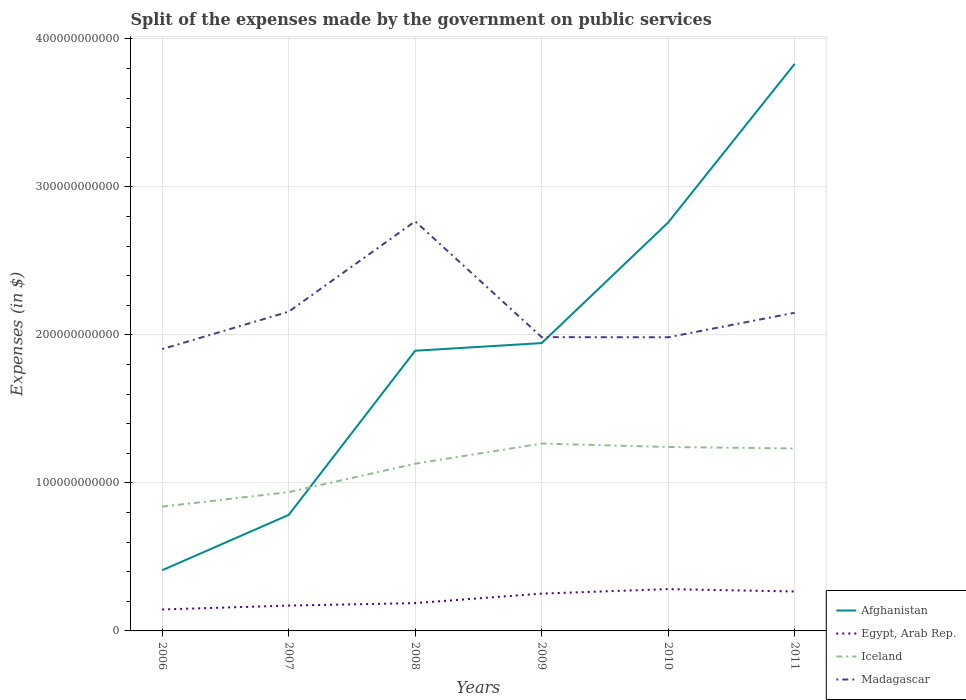How many different coloured lines are there?
Provide a succinct answer. 4. Is the number of lines equal to the number of legend labels?
Make the answer very short. Yes. Across all years, what is the maximum expenses made by the government on public services in Afghanistan?
Offer a very short reply. 4.10e+1. In which year was the expenses made by the government on public services in Egypt, Arab Rep. maximum?
Offer a very short reply. 2006. What is the total expenses made by the government on public services in Iceland in the graph?
Your response must be concise. -4.26e+1. What is the difference between the highest and the second highest expenses made by the government on public services in Madagascar?
Provide a succinct answer. 8.63e+1. How many lines are there?
Your answer should be compact. 4. What is the difference between two consecutive major ticks on the Y-axis?
Your answer should be very brief. 1.00e+11. Does the graph contain any zero values?
Ensure brevity in your answer.  No. Where does the legend appear in the graph?
Offer a terse response. Bottom right. How many legend labels are there?
Make the answer very short. 4. What is the title of the graph?
Make the answer very short. Split of the expenses made by the government on public services. Does "Burkina Faso" appear as one of the legend labels in the graph?
Ensure brevity in your answer.  No. What is the label or title of the Y-axis?
Keep it short and to the point. Expenses (in $). What is the Expenses (in $) in Afghanistan in 2006?
Your response must be concise. 4.10e+1. What is the Expenses (in $) in Egypt, Arab Rep. in 2006?
Ensure brevity in your answer.  1.45e+1. What is the Expenses (in $) in Iceland in 2006?
Ensure brevity in your answer.  8.39e+1. What is the Expenses (in $) of Madagascar in 2006?
Your answer should be very brief. 1.90e+11. What is the Expenses (in $) in Afghanistan in 2007?
Your answer should be very brief. 7.84e+1. What is the Expenses (in $) of Egypt, Arab Rep. in 2007?
Ensure brevity in your answer.  1.71e+1. What is the Expenses (in $) of Iceland in 2007?
Offer a terse response. 9.38e+1. What is the Expenses (in $) of Madagascar in 2007?
Make the answer very short. 2.16e+11. What is the Expenses (in $) in Afghanistan in 2008?
Provide a succinct answer. 1.89e+11. What is the Expenses (in $) in Egypt, Arab Rep. in 2008?
Give a very brief answer. 1.88e+1. What is the Expenses (in $) of Iceland in 2008?
Make the answer very short. 1.13e+11. What is the Expenses (in $) in Madagascar in 2008?
Your answer should be very brief. 2.77e+11. What is the Expenses (in $) of Afghanistan in 2009?
Make the answer very short. 1.94e+11. What is the Expenses (in $) in Egypt, Arab Rep. in 2009?
Make the answer very short. 2.52e+1. What is the Expenses (in $) in Iceland in 2009?
Keep it short and to the point. 1.27e+11. What is the Expenses (in $) in Madagascar in 2009?
Give a very brief answer. 1.98e+11. What is the Expenses (in $) in Afghanistan in 2010?
Ensure brevity in your answer.  2.76e+11. What is the Expenses (in $) in Egypt, Arab Rep. in 2010?
Make the answer very short. 2.82e+1. What is the Expenses (in $) in Iceland in 2010?
Make the answer very short. 1.24e+11. What is the Expenses (in $) in Madagascar in 2010?
Provide a succinct answer. 1.98e+11. What is the Expenses (in $) in Afghanistan in 2011?
Offer a terse response. 3.83e+11. What is the Expenses (in $) of Egypt, Arab Rep. in 2011?
Keep it short and to the point. 2.66e+1. What is the Expenses (in $) in Iceland in 2011?
Give a very brief answer. 1.23e+11. What is the Expenses (in $) of Madagascar in 2011?
Offer a terse response. 2.15e+11. Across all years, what is the maximum Expenses (in $) in Afghanistan?
Provide a short and direct response. 3.83e+11. Across all years, what is the maximum Expenses (in $) in Egypt, Arab Rep.?
Make the answer very short. 2.82e+1. Across all years, what is the maximum Expenses (in $) in Iceland?
Provide a succinct answer. 1.27e+11. Across all years, what is the maximum Expenses (in $) in Madagascar?
Your answer should be compact. 2.77e+11. Across all years, what is the minimum Expenses (in $) of Afghanistan?
Give a very brief answer. 4.10e+1. Across all years, what is the minimum Expenses (in $) of Egypt, Arab Rep.?
Provide a succinct answer. 1.45e+1. Across all years, what is the minimum Expenses (in $) of Iceland?
Ensure brevity in your answer.  8.39e+1. Across all years, what is the minimum Expenses (in $) of Madagascar?
Offer a terse response. 1.90e+11. What is the total Expenses (in $) in Afghanistan in the graph?
Offer a very short reply. 1.16e+12. What is the total Expenses (in $) in Egypt, Arab Rep. in the graph?
Make the answer very short. 1.30e+11. What is the total Expenses (in $) of Iceland in the graph?
Provide a succinct answer. 6.65e+11. What is the total Expenses (in $) in Madagascar in the graph?
Your response must be concise. 1.29e+12. What is the difference between the Expenses (in $) of Afghanistan in 2006 and that in 2007?
Your answer should be compact. -3.74e+1. What is the difference between the Expenses (in $) of Egypt, Arab Rep. in 2006 and that in 2007?
Give a very brief answer. -2.63e+09. What is the difference between the Expenses (in $) of Iceland in 2006 and that in 2007?
Provide a succinct answer. -9.81e+09. What is the difference between the Expenses (in $) of Madagascar in 2006 and that in 2007?
Give a very brief answer. -2.52e+1. What is the difference between the Expenses (in $) of Afghanistan in 2006 and that in 2008?
Keep it short and to the point. -1.48e+11. What is the difference between the Expenses (in $) in Egypt, Arab Rep. in 2006 and that in 2008?
Keep it short and to the point. -4.30e+09. What is the difference between the Expenses (in $) of Iceland in 2006 and that in 2008?
Ensure brevity in your answer.  -2.90e+1. What is the difference between the Expenses (in $) of Madagascar in 2006 and that in 2008?
Make the answer very short. -8.63e+1. What is the difference between the Expenses (in $) of Afghanistan in 2006 and that in 2009?
Make the answer very short. -1.53e+11. What is the difference between the Expenses (in $) of Egypt, Arab Rep. in 2006 and that in 2009?
Give a very brief answer. -1.07e+1. What is the difference between the Expenses (in $) of Iceland in 2006 and that in 2009?
Your response must be concise. -4.26e+1. What is the difference between the Expenses (in $) of Madagascar in 2006 and that in 2009?
Your answer should be very brief. -8.07e+09. What is the difference between the Expenses (in $) of Afghanistan in 2006 and that in 2010?
Your response must be concise. -2.35e+11. What is the difference between the Expenses (in $) of Egypt, Arab Rep. in 2006 and that in 2010?
Ensure brevity in your answer.  -1.38e+1. What is the difference between the Expenses (in $) of Iceland in 2006 and that in 2010?
Offer a terse response. -4.03e+1. What is the difference between the Expenses (in $) of Madagascar in 2006 and that in 2010?
Offer a very short reply. -7.98e+09. What is the difference between the Expenses (in $) in Afghanistan in 2006 and that in 2011?
Your answer should be very brief. -3.42e+11. What is the difference between the Expenses (in $) in Egypt, Arab Rep. in 2006 and that in 2011?
Provide a short and direct response. -1.22e+1. What is the difference between the Expenses (in $) of Iceland in 2006 and that in 2011?
Offer a terse response. -3.93e+1. What is the difference between the Expenses (in $) in Madagascar in 2006 and that in 2011?
Give a very brief answer. -2.45e+1. What is the difference between the Expenses (in $) of Afghanistan in 2007 and that in 2008?
Provide a short and direct response. -1.11e+11. What is the difference between the Expenses (in $) of Egypt, Arab Rep. in 2007 and that in 2008?
Ensure brevity in your answer.  -1.67e+09. What is the difference between the Expenses (in $) of Iceland in 2007 and that in 2008?
Your response must be concise. -1.92e+1. What is the difference between the Expenses (in $) in Madagascar in 2007 and that in 2008?
Offer a very short reply. -6.11e+1. What is the difference between the Expenses (in $) in Afghanistan in 2007 and that in 2009?
Provide a succinct answer. -1.16e+11. What is the difference between the Expenses (in $) of Egypt, Arab Rep. in 2007 and that in 2009?
Your answer should be very brief. -8.08e+09. What is the difference between the Expenses (in $) in Iceland in 2007 and that in 2009?
Make the answer very short. -3.28e+1. What is the difference between the Expenses (in $) in Madagascar in 2007 and that in 2009?
Ensure brevity in your answer.  1.72e+1. What is the difference between the Expenses (in $) in Afghanistan in 2007 and that in 2010?
Provide a short and direct response. -1.98e+11. What is the difference between the Expenses (in $) in Egypt, Arab Rep. in 2007 and that in 2010?
Your answer should be compact. -1.11e+1. What is the difference between the Expenses (in $) of Iceland in 2007 and that in 2010?
Provide a succinct answer. -3.05e+1. What is the difference between the Expenses (in $) in Madagascar in 2007 and that in 2010?
Ensure brevity in your answer.  1.73e+1. What is the difference between the Expenses (in $) of Afghanistan in 2007 and that in 2011?
Give a very brief answer. -3.05e+11. What is the difference between the Expenses (in $) of Egypt, Arab Rep. in 2007 and that in 2011?
Make the answer very short. -9.52e+09. What is the difference between the Expenses (in $) of Iceland in 2007 and that in 2011?
Provide a short and direct response. -2.95e+1. What is the difference between the Expenses (in $) of Madagascar in 2007 and that in 2011?
Your response must be concise. 7.27e+08. What is the difference between the Expenses (in $) in Afghanistan in 2008 and that in 2009?
Make the answer very short. -5.15e+09. What is the difference between the Expenses (in $) of Egypt, Arab Rep. in 2008 and that in 2009?
Give a very brief answer. -6.41e+09. What is the difference between the Expenses (in $) in Iceland in 2008 and that in 2009?
Ensure brevity in your answer.  -1.36e+1. What is the difference between the Expenses (in $) in Madagascar in 2008 and that in 2009?
Your response must be concise. 7.82e+1. What is the difference between the Expenses (in $) in Afghanistan in 2008 and that in 2010?
Provide a succinct answer. -8.66e+1. What is the difference between the Expenses (in $) in Egypt, Arab Rep. in 2008 and that in 2010?
Your response must be concise. -9.46e+09. What is the difference between the Expenses (in $) in Iceland in 2008 and that in 2010?
Ensure brevity in your answer.  -1.13e+1. What is the difference between the Expenses (in $) of Madagascar in 2008 and that in 2010?
Offer a terse response. 7.83e+1. What is the difference between the Expenses (in $) in Afghanistan in 2008 and that in 2011?
Provide a succinct answer. -1.94e+11. What is the difference between the Expenses (in $) in Egypt, Arab Rep. in 2008 and that in 2011?
Keep it short and to the point. -7.86e+09. What is the difference between the Expenses (in $) of Iceland in 2008 and that in 2011?
Provide a succinct answer. -1.03e+1. What is the difference between the Expenses (in $) in Madagascar in 2008 and that in 2011?
Give a very brief answer. 6.18e+1. What is the difference between the Expenses (in $) of Afghanistan in 2009 and that in 2010?
Provide a succinct answer. -8.15e+1. What is the difference between the Expenses (in $) in Egypt, Arab Rep. in 2009 and that in 2010?
Provide a short and direct response. -3.04e+09. What is the difference between the Expenses (in $) in Iceland in 2009 and that in 2010?
Your response must be concise. 2.31e+09. What is the difference between the Expenses (in $) of Madagascar in 2009 and that in 2010?
Provide a succinct answer. 9.30e+07. What is the difference between the Expenses (in $) of Afghanistan in 2009 and that in 2011?
Offer a terse response. -1.89e+11. What is the difference between the Expenses (in $) of Egypt, Arab Rep. in 2009 and that in 2011?
Keep it short and to the point. -1.44e+09. What is the difference between the Expenses (in $) of Iceland in 2009 and that in 2011?
Your answer should be very brief. 3.32e+09. What is the difference between the Expenses (in $) of Madagascar in 2009 and that in 2011?
Give a very brief answer. -1.65e+1. What is the difference between the Expenses (in $) of Afghanistan in 2010 and that in 2011?
Ensure brevity in your answer.  -1.07e+11. What is the difference between the Expenses (in $) in Egypt, Arab Rep. in 2010 and that in 2011?
Your answer should be very brief. 1.60e+09. What is the difference between the Expenses (in $) in Iceland in 2010 and that in 2011?
Your answer should be very brief. 1.01e+09. What is the difference between the Expenses (in $) of Madagascar in 2010 and that in 2011?
Your answer should be very brief. -1.65e+1. What is the difference between the Expenses (in $) in Afghanistan in 2006 and the Expenses (in $) in Egypt, Arab Rep. in 2007?
Your answer should be compact. 2.39e+1. What is the difference between the Expenses (in $) in Afghanistan in 2006 and the Expenses (in $) in Iceland in 2007?
Offer a terse response. -5.28e+1. What is the difference between the Expenses (in $) of Afghanistan in 2006 and the Expenses (in $) of Madagascar in 2007?
Your answer should be very brief. -1.75e+11. What is the difference between the Expenses (in $) in Egypt, Arab Rep. in 2006 and the Expenses (in $) in Iceland in 2007?
Your response must be concise. -7.93e+1. What is the difference between the Expenses (in $) of Egypt, Arab Rep. in 2006 and the Expenses (in $) of Madagascar in 2007?
Your answer should be compact. -2.01e+11. What is the difference between the Expenses (in $) of Iceland in 2006 and the Expenses (in $) of Madagascar in 2007?
Your answer should be very brief. -1.32e+11. What is the difference between the Expenses (in $) in Afghanistan in 2006 and the Expenses (in $) in Egypt, Arab Rep. in 2008?
Your answer should be very brief. 2.22e+1. What is the difference between the Expenses (in $) in Afghanistan in 2006 and the Expenses (in $) in Iceland in 2008?
Make the answer very short. -7.20e+1. What is the difference between the Expenses (in $) of Afghanistan in 2006 and the Expenses (in $) of Madagascar in 2008?
Make the answer very short. -2.36e+11. What is the difference between the Expenses (in $) in Egypt, Arab Rep. in 2006 and the Expenses (in $) in Iceland in 2008?
Keep it short and to the point. -9.85e+1. What is the difference between the Expenses (in $) of Egypt, Arab Rep. in 2006 and the Expenses (in $) of Madagascar in 2008?
Offer a very short reply. -2.62e+11. What is the difference between the Expenses (in $) in Iceland in 2006 and the Expenses (in $) in Madagascar in 2008?
Provide a succinct answer. -1.93e+11. What is the difference between the Expenses (in $) of Afghanistan in 2006 and the Expenses (in $) of Egypt, Arab Rep. in 2009?
Provide a succinct answer. 1.58e+1. What is the difference between the Expenses (in $) in Afghanistan in 2006 and the Expenses (in $) in Iceland in 2009?
Your answer should be compact. -8.56e+1. What is the difference between the Expenses (in $) of Afghanistan in 2006 and the Expenses (in $) of Madagascar in 2009?
Your response must be concise. -1.57e+11. What is the difference between the Expenses (in $) in Egypt, Arab Rep. in 2006 and the Expenses (in $) in Iceland in 2009?
Provide a short and direct response. -1.12e+11. What is the difference between the Expenses (in $) of Egypt, Arab Rep. in 2006 and the Expenses (in $) of Madagascar in 2009?
Keep it short and to the point. -1.84e+11. What is the difference between the Expenses (in $) of Iceland in 2006 and the Expenses (in $) of Madagascar in 2009?
Offer a very short reply. -1.15e+11. What is the difference between the Expenses (in $) in Afghanistan in 2006 and the Expenses (in $) in Egypt, Arab Rep. in 2010?
Ensure brevity in your answer.  1.27e+1. What is the difference between the Expenses (in $) in Afghanistan in 2006 and the Expenses (in $) in Iceland in 2010?
Provide a succinct answer. -8.33e+1. What is the difference between the Expenses (in $) of Afghanistan in 2006 and the Expenses (in $) of Madagascar in 2010?
Offer a very short reply. -1.57e+11. What is the difference between the Expenses (in $) in Egypt, Arab Rep. in 2006 and the Expenses (in $) in Iceland in 2010?
Keep it short and to the point. -1.10e+11. What is the difference between the Expenses (in $) of Egypt, Arab Rep. in 2006 and the Expenses (in $) of Madagascar in 2010?
Your answer should be very brief. -1.84e+11. What is the difference between the Expenses (in $) in Iceland in 2006 and the Expenses (in $) in Madagascar in 2010?
Ensure brevity in your answer.  -1.14e+11. What is the difference between the Expenses (in $) in Afghanistan in 2006 and the Expenses (in $) in Egypt, Arab Rep. in 2011?
Offer a very short reply. 1.43e+1. What is the difference between the Expenses (in $) of Afghanistan in 2006 and the Expenses (in $) of Iceland in 2011?
Provide a succinct answer. -8.23e+1. What is the difference between the Expenses (in $) in Afghanistan in 2006 and the Expenses (in $) in Madagascar in 2011?
Offer a terse response. -1.74e+11. What is the difference between the Expenses (in $) in Egypt, Arab Rep. in 2006 and the Expenses (in $) in Iceland in 2011?
Your answer should be compact. -1.09e+11. What is the difference between the Expenses (in $) of Egypt, Arab Rep. in 2006 and the Expenses (in $) of Madagascar in 2011?
Ensure brevity in your answer.  -2.00e+11. What is the difference between the Expenses (in $) of Iceland in 2006 and the Expenses (in $) of Madagascar in 2011?
Your response must be concise. -1.31e+11. What is the difference between the Expenses (in $) in Afghanistan in 2007 and the Expenses (in $) in Egypt, Arab Rep. in 2008?
Your answer should be compact. 5.96e+1. What is the difference between the Expenses (in $) of Afghanistan in 2007 and the Expenses (in $) of Iceland in 2008?
Offer a very short reply. -3.46e+1. What is the difference between the Expenses (in $) in Afghanistan in 2007 and the Expenses (in $) in Madagascar in 2008?
Your answer should be very brief. -1.98e+11. What is the difference between the Expenses (in $) of Egypt, Arab Rep. in 2007 and the Expenses (in $) of Iceland in 2008?
Offer a terse response. -9.58e+1. What is the difference between the Expenses (in $) of Egypt, Arab Rep. in 2007 and the Expenses (in $) of Madagascar in 2008?
Make the answer very short. -2.60e+11. What is the difference between the Expenses (in $) of Iceland in 2007 and the Expenses (in $) of Madagascar in 2008?
Provide a succinct answer. -1.83e+11. What is the difference between the Expenses (in $) in Afghanistan in 2007 and the Expenses (in $) in Egypt, Arab Rep. in 2009?
Provide a short and direct response. 5.32e+1. What is the difference between the Expenses (in $) in Afghanistan in 2007 and the Expenses (in $) in Iceland in 2009?
Keep it short and to the point. -4.82e+1. What is the difference between the Expenses (in $) of Afghanistan in 2007 and the Expenses (in $) of Madagascar in 2009?
Make the answer very short. -1.20e+11. What is the difference between the Expenses (in $) in Egypt, Arab Rep. in 2007 and the Expenses (in $) in Iceland in 2009?
Provide a short and direct response. -1.09e+11. What is the difference between the Expenses (in $) of Egypt, Arab Rep. in 2007 and the Expenses (in $) of Madagascar in 2009?
Provide a succinct answer. -1.81e+11. What is the difference between the Expenses (in $) of Iceland in 2007 and the Expenses (in $) of Madagascar in 2009?
Offer a very short reply. -1.05e+11. What is the difference between the Expenses (in $) in Afghanistan in 2007 and the Expenses (in $) in Egypt, Arab Rep. in 2010?
Your answer should be compact. 5.01e+1. What is the difference between the Expenses (in $) of Afghanistan in 2007 and the Expenses (in $) of Iceland in 2010?
Make the answer very short. -4.59e+1. What is the difference between the Expenses (in $) in Afghanistan in 2007 and the Expenses (in $) in Madagascar in 2010?
Offer a very short reply. -1.20e+11. What is the difference between the Expenses (in $) in Egypt, Arab Rep. in 2007 and the Expenses (in $) in Iceland in 2010?
Ensure brevity in your answer.  -1.07e+11. What is the difference between the Expenses (in $) of Egypt, Arab Rep. in 2007 and the Expenses (in $) of Madagascar in 2010?
Make the answer very short. -1.81e+11. What is the difference between the Expenses (in $) in Iceland in 2007 and the Expenses (in $) in Madagascar in 2010?
Your answer should be compact. -1.05e+11. What is the difference between the Expenses (in $) of Afghanistan in 2007 and the Expenses (in $) of Egypt, Arab Rep. in 2011?
Provide a short and direct response. 5.17e+1. What is the difference between the Expenses (in $) of Afghanistan in 2007 and the Expenses (in $) of Iceland in 2011?
Provide a short and direct response. -4.49e+1. What is the difference between the Expenses (in $) in Afghanistan in 2007 and the Expenses (in $) in Madagascar in 2011?
Make the answer very short. -1.37e+11. What is the difference between the Expenses (in $) of Egypt, Arab Rep. in 2007 and the Expenses (in $) of Iceland in 2011?
Provide a short and direct response. -1.06e+11. What is the difference between the Expenses (in $) of Egypt, Arab Rep. in 2007 and the Expenses (in $) of Madagascar in 2011?
Offer a very short reply. -1.98e+11. What is the difference between the Expenses (in $) in Iceland in 2007 and the Expenses (in $) in Madagascar in 2011?
Your answer should be compact. -1.21e+11. What is the difference between the Expenses (in $) of Afghanistan in 2008 and the Expenses (in $) of Egypt, Arab Rep. in 2009?
Keep it short and to the point. 1.64e+11. What is the difference between the Expenses (in $) of Afghanistan in 2008 and the Expenses (in $) of Iceland in 2009?
Keep it short and to the point. 6.27e+1. What is the difference between the Expenses (in $) of Afghanistan in 2008 and the Expenses (in $) of Madagascar in 2009?
Provide a short and direct response. -9.19e+09. What is the difference between the Expenses (in $) of Egypt, Arab Rep. in 2008 and the Expenses (in $) of Iceland in 2009?
Keep it short and to the point. -1.08e+11. What is the difference between the Expenses (in $) of Egypt, Arab Rep. in 2008 and the Expenses (in $) of Madagascar in 2009?
Provide a succinct answer. -1.80e+11. What is the difference between the Expenses (in $) in Iceland in 2008 and the Expenses (in $) in Madagascar in 2009?
Ensure brevity in your answer.  -8.55e+1. What is the difference between the Expenses (in $) of Afghanistan in 2008 and the Expenses (in $) of Egypt, Arab Rep. in 2010?
Your answer should be very brief. 1.61e+11. What is the difference between the Expenses (in $) of Afghanistan in 2008 and the Expenses (in $) of Iceland in 2010?
Offer a very short reply. 6.50e+1. What is the difference between the Expenses (in $) in Afghanistan in 2008 and the Expenses (in $) in Madagascar in 2010?
Offer a very short reply. -9.09e+09. What is the difference between the Expenses (in $) of Egypt, Arab Rep. in 2008 and the Expenses (in $) of Iceland in 2010?
Your answer should be compact. -1.05e+11. What is the difference between the Expenses (in $) in Egypt, Arab Rep. in 2008 and the Expenses (in $) in Madagascar in 2010?
Provide a succinct answer. -1.80e+11. What is the difference between the Expenses (in $) of Iceland in 2008 and the Expenses (in $) of Madagascar in 2010?
Your response must be concise. -8.54e+1. What is the difference between the Expenses (in $) of Afghanistan in 2008 and the Expenses (in $) of Egypt, Arab Rep. in 2011?
Ensure brevity in your answer.  1.63e+11. What is the difference between the Expenses (in $) in Afghanistan in 2008 and the Expenses (in $) in Iceland in 2011?
Offer a terse response. 6.60e+1. What is the difference between the Expenses (in $) in Afghanistan in 2008 and the Expenses (in $) in Madagascar in 2011?
Give a very brief answer. -2.56e+1. What is the difference between the Expenses (in $) of Egypt, Arab Rep. in 2008 and the Expenses (in $) of Iceland in 2011?
Your answer should be very brief. -1.04e+11. What is the difference between the Expenses (in $) in Egypt, Arab Rep. in 2008 and the Expenses (in $) in Madagascar in 2011?
Your answer should be very brief. -1.96e+11. What is the difference between the Expenses (in $) of Iceland in 2008 and the Expenses (in $) of Madagascar in 2011?
Offer a very short reply. -1.02e+11. What is the difference between the Expenses (in $) in Afghanistan in 2009 and the Expenses (in $) in Egypt, Arab Rep. in 2010?
Keep it short and to the point. 1.66e+11. What is the difference between the Expenses (in $) in Afghanistan in 2009 and the Expenses (in $) in Iceland in 2010?
Offer a very short reply. 7.02e+1. What is the difference between the Expenses (in $) in Afghanistan in 2009 and the Expenses (in $) in Madagascar in 2010?
Give a very brief answer. -3.94e+09. What is the difference between the Expenses (in $) of Egypt, Arab Rep. in 2009 and the Expenses (in $) of Iceland in 2010?
Give a very brief answer. -9.91e+1. What is the difference between the Expenses (in $) in Egypt, Arab Rep. in 2009 and the Expenses (in $) in Madagascar in 2010?
Your answer should be very brief. -1.73e+11. What is the difference between the Expenses (in $) in Iceland in 2009 and the Expenses (in $) in Madagascar in 2010?
Your answer should be very brief. -7.18e+1. What is the difference between the Expenses (in $) of Afghanistan in 2009 and the Expenses (in $) of Egypt, Arab Rep. in 2011?
Provide a short and direct response. 1.68e+11. What is the difference between the Expenses (in $) of Afghanistan in 2009 and the Expenses (in $) of Iceland in 2011?
Keep it short and to the point. 7.12e+1. What is the difference between the Expenses (in $) of Afghanistan in 2009 and the Expenses (in $) of Madagascar in 2011?
Provide a succinct answer. -2.05e+1. What is the difference between the Expenses (in $) in Egypt, Arab Rep. in 2009 and the Expenses (in $) in Iceland in 2011?
Your answer should be very brief. -9.80e+1. What is the difference between the Expenses (in $) in Egypt, Arab Rep. in 2009 and the Expenses (in $) in Madagascar in 2011?
Your response must be concise. -1.90e+11. What is the difference between the Expenses (in $) of Iceland in 2009 and the Expenses (in $) of Madagascar in 2011?
Your answer should be very brief. -8.84e+1. What is the difference between the Expenses (in $) in Afghanistan in 2010 and the Expenses (in $) in Egypt, Arab Rep. in 2011?
Give a very brief answer. 2.49e+11. What is the difference between the Expenses (in $) of Afghanistan in 2010 and the Expenses (in $) of Iceland in 2011?
Ensure brevity in your answer.  1.53e+11. What is the difference between the Expenses (in $) of Afghanistan in 2010 and the Expenses (in $) of Madagascar in 2011?
Keep it short and to the point. 6.10e+1. What is the difference between the Expenses (in $) in Egypt, Arab Rep. in 2010 and the Expenses (in $) in Iceland in 2011?
Offer a very short reply. -9.50e+1. What is the difference between the Expenses (in $) in Egypt, Arab Rep. in 2010 and the Expenses (in $) in Madagascar in 2011?
Offer a very short reply. -1.87e+11. What is the difference between the Expenses (in $) of Iceland in 2010 and the Expenses (in $) of Madagascar in 2011?
Your answer should be very brief. -9.07e+1. What is the average Expenses (in $) in Afghanistan per year?
Offer a very short reply. 1.94e+11. What is the average Expenses (in $) of Egypt, Arab Rep. per year?
Offer a very short reply. 2.17e+1. What is the average Expenses (in $) of Iceland per year?
Provide a succinct answer. 1.11e+11. What is the average Expenses (in $) in Madagascar per year?
Offer a very short reply. 2.16e+11. In the year 2006, what is the difference between the Expenses (in $) in Afghanistan and Expenses (in $) in Egypt, Arab Rep.?
Your response must be concise. 2.65e+1. In the year 2006, what is the difference between the Expenses (in $) in Afghanistan and Expenses (in $) in Iceland?
Provide a succinct answer. -4.30e+1. In the year 2006, what is the difference between the Expenses (in $) in Afghanistan and Expenses (in $) in Madagascar?
Ensure brevity in your answer.  -1.49e+11. In the year 2006, what is the difference between the Expenses (in $) in Egypt, Arab Rep. and Expenses (in $) in Iceland?
Make the answer very short. -6.94e+1. In the year 2006, what is the difference between the Expenses (in $) of Egypt, Arab Rep. and Expenses (in $) of Madagascar?
Ensure brevity in your answer.  -1.76e+11. In the year 2006, what is the difference between the Expenses (in $) of Iceland and Expenses (in $) of Madagascar?
Make the answer very short. -1.06e+11. In the year 2007, what is the difference between the Expenses (in $) in Afghanistan and Expenses (in $) in Egypt, Arab Rep.?
Ensure brevity in your answer.  6.12e+1. In the year 2007, what is the difference between the Expenses (in $) of Afghanistan and Expenses (in $) of Iceland?
Make the answer very short. -1.54e+1. In the year 2007, what is the difference between the Expenses (in $) of Afghanistan and Expenses (in $) of Madagascar?
Your response must be concise. -1.37e+11. In the year 2007, what is the difference between the Expenses (in $) of Egypt, Arab Rep. and Expenses (in $) of Iceland?
Give a very brief answer. -7.66e+1. In the year 2007, what is the difference between the Expenses (in $) in Egypt, Arab Rep. and Expenses (in $) in Madagascar?
Give a very brief answer. -1.99e+11. In the year 2007, what is the difference between the Expenses (in $) of Iceland and Expenses (in $) of Madagascar?
Provide a short and direct response. -1.22e+11. In the year 2008, what is the difference between the Expenses (in $) of Afghanistan and Expenses (in $) of Egypt, Arab Rep.?
Keep it short and to the point. 1.70e+11. In the year 2008, what is the difference between the Expenses (in $) of Afghanistan and Expenses (in $) of Iceland?
Provide a succinct answer. 7.63e+1. In the year 2008, what is the difference between the Expenses (in $) of Afghanistan and Expenses (in $) of Madagascar?
Your answer should be compact. -8.74e+1. In the year 2008, what is the difference between the Expenses (in $) in Egypt, Arab Rep. and Expenses (in $) in Iceland?
Make the answer very short. -9.42e+1. In the year 2008, what is the difference between the Expenses (in $) of Egypt, Arab Rep. and Expenses (in $) of Madagascar?
Your response must be concise. -2.58e+11. In the year 2008, what is the difference between the Expenses (in $) of Iceland and Expenses (in $) of Madagascar?
Your response must be concise. -1.64e+11. In the year 2009, what is the difference between the Expenses (in $) in Afghanistan and Expenses (in $) in Egypt, Arab Rep.?
Make the answer very short. 1.69e+11. In the year 2009, what is the difference between the Expenses (in $) of Afghanistan and Expenses (in $) of Iceland?
Your answer should be compact. 6.79e+1. In the year 2009, what is the difference between the Expenses (in $) in Afghanistan and Expenses (in $) in Madagascar?
Provide a short and direct response. -4.03e+09. In the year 2009, what is the difference between the Expenses (in $) of Egypt, Arab Rep. and Expenses (in $) of Iceland?
Provide a succinct answer. -1.01e+11. In the year 2009, what is the difference between the Expenses (in $) in Egypt, Arab Rep. and Expenses (in $) in Madagascar?
Provide a short and direct response. -1.73e+11. In the year 2009, what is the difference between the Expenses (in $) of Iceland and Expenses (in $) of Madagascar?
Make the answer very short. -7.19e+1. In the year 2010, what is the difference between the Expenses (in $) of Afghanistan and Expenses (in $) of Egypt, Arab Rep.?
Ensure brevity in your answer.  2.48e+11. In the year 2010, what is the difference between the Expenses (in $) of Afghanistan and Expenses (in $) of Iceland?
Keep it short and to the point. 1.52e+11. In the year 2010, what is the difference between the Expenses (in $) of Afghanistan and Expenses (in $) of Madagascar?
Provide a short and direct response. 7.76e+1. In the year 2010, what is the difference between the Expenses (in $) in Egypt, Arab Rep. and Expenses (in $) in Iceland?
Keep it short and to the point. -9.60e+1. In the year 2010, what is the difference between the Expenses (in $) of Egypt, Arab Rep. and Expenses (in $) of Madagascar?
Offer a very short reply. -1.70e+11. In the year 2010, what is the difference between the Expenses (in $) of Iceland and Expenses (in $) of Madagascar?
Ensure brevity in your answer.  -7.41e+1. In the year 2011, what is the difference between the Expenses (in $) of Afghanistan and Expenses (in $) of Egypt, Arab Rep.?
Provide a short and direct response. 3.56e+11. In the year 2011, what is the difference between the Expenses (in $) in Afghanistan and Expenses (in $) in Iceland?
Provide a short and direct response. 2.60e+11. In the year 2011, what is the difference between the Expenses (in $) in Afghanistan and Expenses (in $) in Madagascar?
Your response must be concise. 1.68e+11. In the year 2011, what is the difference between the Expenses (in $) in Egypt, Arab Rep. and Expenses (in $) in Iceland?
Offer a terse response. -9.66e+1. In the year 2011, what is the difference between the Expenses (in $) of Egypt, Arab Rep. and Expenses (in $) of Madagascar?
Make the answer very short. -1.88e+11. In the year 2011, what is the difference between the Expenses (in $) in Iceland and Expenses (in $) in Madagascar?
Give a very brief answer. -9.17e+1. What is the ratio of the Expenses (in $) of Afghanistan in 2006 to that in 2007?
Offer a terse response. 0.52. What is the ratio of the Expenses (in $) of Egypt, Arab Rep. in 2006 to that in 2007?
Give a very brief answer. 0.85. What is the ratio of the Expenses (in $) in Iceland in 2006 to that in 2007?
Your response must be concise. 0.9. What is the ratio of the Expenses (in $) in Madagascar in 2006 to that in 2007?
Provide a succinct answer. 0.88. What is the ratio of the Expenses (in $) in Afghanistan in 2006 to that in 2008?
Your answer should be very brief. 0.22. What is the ratio of the Expenses (in $) of Egypt, Arab Rep. in 2006 to that in 2008?
Your answer should be compact. 0.77. What is the ratio of the Expenses (in $) in Iceland in 2006 to that in 2008?
Offer a terse response. 0.74. What is the ratio of the Expenses (in $) in Madagascar in 2006 to that in 2008?
Give a very brief answer. 0.69. What is the ratio of the Expenses (in $) in Afghanistan in 2006 to that in 2009?
Offer a terse response. 0.21. What is the ratio of the Expenses (in $) in Egypt, Arab Rep. in 2006 to that in 2009?
Offer a very short reply. 0.58. What is the ratio of the Expenses (in $) of Iceland in 2006 to that in 2009?
Offer a very short reply. 0.66. What is the ratio of the Expenses (in $) in Madagascar in 2006 to that in 2009?
Your answer should be very brief. 0.96. What is the ratio of the Expenses (in $) of Afghanistan in 2006 to that in 2010?
Offer a terse response. 0.15. What is the ratio of the Expenses (in $) of Egypt, Arab Rep. in 2006 to that in 2010?
Give a very brief answer. 0.51. What is the ratio of the Expenses (in $) in Iceland in 2006 to that in 2010?
Provide a short and direct response. 0.68. What is the ratio of the Expenses (in $) of Madagascar in 2006 to that in 2010?
Give a very brief answer. 0.96. What is the ratio of the Expenses (in $) in Afghanistan in 2006 to that in 2011?
Provide a short and direct response. 0.11. What is the ratio of the Expenses (in $) of Egypt, Arab Rep. in 2006 to that in 2011?
Your answer should be very brief. 0.54. What is the ratio of the Expenses (in $) in Iceland in 2006 to that in 2011?
Make the answer very short. 0.68. What is the ratio of the Expenses (in $) in Madagascar in 2006 to that in 2011?
Provide a succinct answer. 0.89. What is the ratio of the Expenses (in $) of Afghanistan in 2007 to that in 2008?
Ensure brevity in your answer.  0.41. What is the ratio of the Expenses (in $) of Egypt, Arab Rep. in 2007 to that in 2008?
Make the answer very short. 0.91. What is the ratio of the Expenses (in $) of Iceland in 2007 to that in 2008?
Your answer should be compact. 0.83. What is the ratio of the Expenses (in $) of Madagascar in 2007 to that in 2008?
Make the answer very short. 0.78. What is the ratio of the Expenses (in $) of Afghanistan in 2007 to that in 2009?
Offer a very short reply. 0.4. What is the ratio of the Expenses (in $) in Egypt, Arab Rep. in 2007 to that in 2009?
Provide a short and direct response. 0.68. What is the ratio of the Expenses (in $) in Iceland in 2007 to that in 2009?
Give a very brief answer. 0.74. What is the ratio of the Expenses (in $) in Madagascar in 2007 to that in 2009?
Provide a succinct answer. 1.09. What is the ratio of the Expenses (in $) in Afghanistan in 2007 to that in 2010?
Your answer should be compact. 0.28. What is the ratio of the Expenses (in $) in Egypt, Arab Rep. in 2007 to that in 2010?
Ensure brevity in your answer.  0.61. What is the ratio of the Expenses (in $) in Iceland in 2007 to that in 2010?
Provide a short and direct response. 0.75. What is the ratio of the Expenses (in $) in Madagascar in 2007 to that in 2010?
Ensure brevity in your answer.  1.09. What is the ratio of the Expenses (in $) of Afghanistan in 2007 to that in 2011?
Provide a short and direct response. 0.2. What is the ratio of the Expenses (in $) in Egypt, Arab Rep. in 2007 to that in 2011?
Provide a short and direct response. 0.64. What is the ratio of the Expenses (in $) in Iceland in 2007 to that in 2011?
Keep it short and to the point. 0.76. What is the ratio of the Expenses (in $) of Afghanistan in 2008 to that in 2009?
Keep it short and to the point. 0.97. What is the ratio of the Expenses (in $) of Egypt, Arab Rep. in 2008 to that in 2009?
Ensure brevity in your answer.  0.75. What is the ratio of the Expenses (in $) of Iceland in 2008 to that in 2009?
Give a very brief answer. 0.89. What is the ratio of the Expenses (in $) in Madagascar in 2008 to that in 2009?
Ensure brevity in your answer.  1.39. What is the ratio of the Expenses (in $) of Afghanistan in 2008 to that in 2010?
Offer a very short reply. 0.69. What is the ratio of the Expenses (in $) of Egypt, Arab Rep. in 2008 to that in 2010?
Your response must be concise. 0.67. What is the ratio of the Expenses (in $) of Iceland in 2008 to that in 2010?
Your response must be concise. 0.91. What is the ratio of the Expenses (in $) of Madagascar in 2008 to that in 2010?
Provide a succinct answer. 1.39. What is the ratio of the Expenses (in $) in Afghanistan in 2008 to that in 2011?
Provide a short and direct response. 0.49. What is the ratio of the Expenses (in $) in Egypt, Arab Rep. in 2008 to that in 2011?
Your answer should be compact. 0.71. What is the ratio of the Expenses (in $) in Iceland in 2008 to that in 2011?
Make the answer very short. 0.92. What is the ratio of the Expenses (in $) in Madagascar in 2008 to that in 2011?
Your response must be concise. 1.29. What is the ratio of the Expenses (in $) in Afghanistan in 2009 to that in 2010?
Ensure brevity in your answer.  0.7. What is the ratio of the Expenses (in $) in Egypt, Arab Rep. in 2009 to that in 2010?
Make the answer very short. 0.89. What is the ratio of the Expenses (in $) in Iceland in 2009 to that in 2010?
Offer a very short reply. 1.02. What is the ratio of the Expenses (in $) in Madagascar in 2009 to that in 2010?
Offer a very short reply. 1. What is the ratio of the Expenses (in $) in Afghanistan in 2009 to that in 2011?
Give a very brief answer. 0.51. What is the ratio of the Expenses (in $) of Egypt, Arab Rep. in 2009 to that in 2011?
Provide a succinct answer. 0.95. What is the ratio of the Expenses (in $) of Iceland in 2009 to that in 2011?
Provide a succinct answer. 1.03. What is the ratio of the Expenses (in $) in Madagascar in 2009 to that in 2011?
Offer a very short reply. 0.92. What is the ratio of the Expenses (in $) of Afghanistan in 2010 to that in 2011?
Your answer should be compact. 0.72. What is the ratio of the Expenses (in $) of Egypt, Arab Rep. in 2010 to that in 2011?
Keep it short and to the point. 1.06. What is the ratio of the Expenses (in $) in Iceland in 2010 to that in 2011?
Keep it short and to the point. 1.01. What is the ratio of the Expenses (in $) of Madagascar in 2010 to that in 2011?
Offer a very short reply. 0.92. What is the difference between the highest and the second highest Expenses (in $) in Afghanistan?
Provide a succinct answer. 1.07e+11. What is the difference between the highest and the second highest Expenses (in $) in Egypt, Arab Rep.?
Provide a succinct answer. 1.60e+09. What is the difference between the highest and the second highest Expenses (in $) of Iceland?
Offer a terse response. 2.31e+09. What is the difference between the highest and the second highest Expenses (in $) of Madagascar?
Provide a short and direct response. 6.11e+1. What is the difference between the highest and the lowest Expenses (in $) in Afghanistan?
Offer a very short reply. 3.42e+11. What is the difference between the highest and the lowest Expenses (in $) of Egypt, Arab Rep.?
Your response must be concise. 1.38e+1. What is the difference between the highest and the lowest Expenses (in $) of Iceland?
Your response must be concise. 4.26e+1. What is the difference between the highest and the lowest Expenses (in $) in Madagascar?
Your answer should be compact. 8.63e+1. 